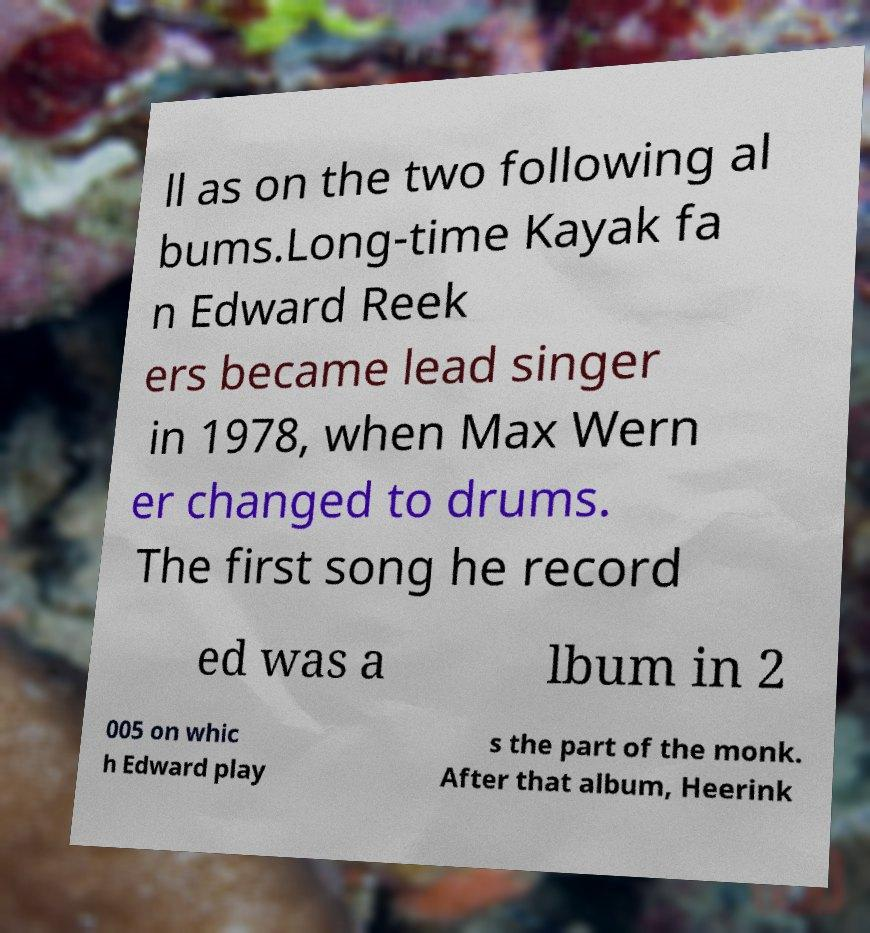Can you read and provide the text displayed in the image?This photo seems to have some interesting text. Can you extract and type it out for me? ll as on the two following al bums.Long-time Kayak fa n Edward Reek ers became lead singer in 1978, when Max Wern er changed to drums. The first song he record ed was a lbum in 2 005 on whic h Edward play s the part of the monk. After that album, Heerink 